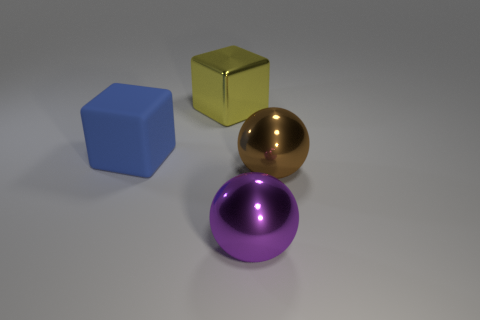Add 3 small yellow shiny things. How many objects exist? 7 Subtract 0 green cubes. How many objects are left? 4 Subtract all large yellow blocks. Subtract all large matte things. How many objects are left? 2 Add 4 large spheres. How many large spheres are left? 6 Add 2 purple objects. How many purple objects exist? 3 